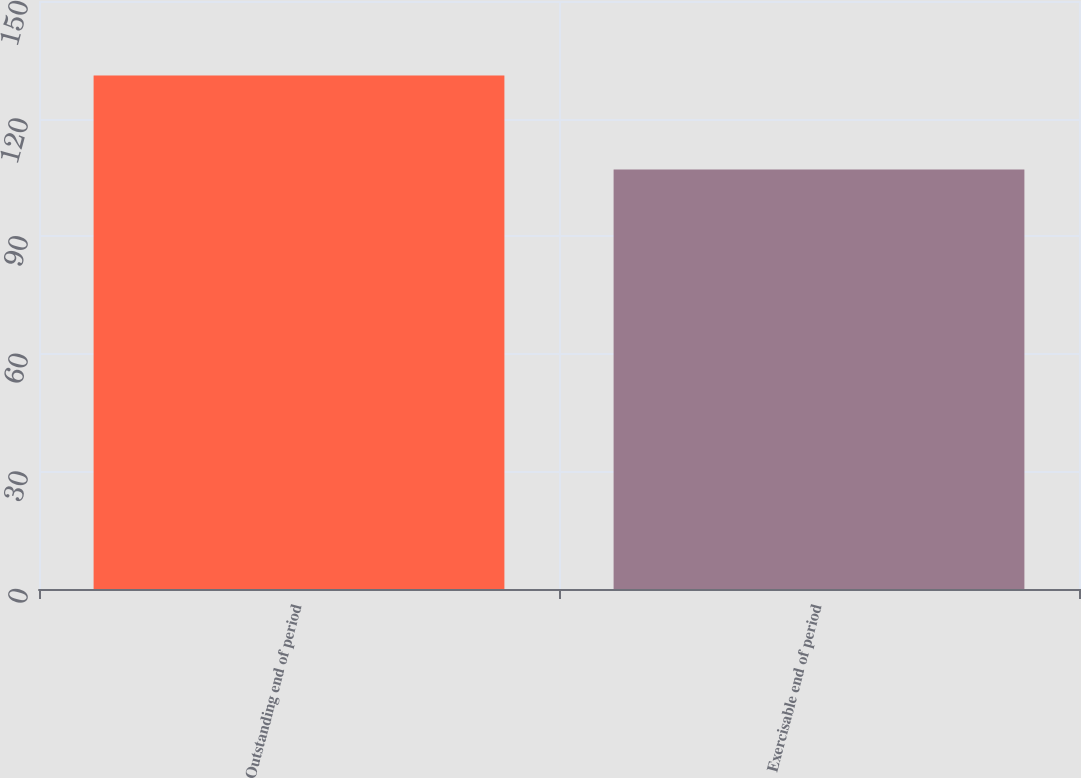Convert chart to OTSL. <chart><loc_0><loc_0><loc_500><loc_500><bar_chart><fcel>Outstanding end of period<fcel>Exercisable end of period<nl><fcel>131<fcel>107<nl></chart> 